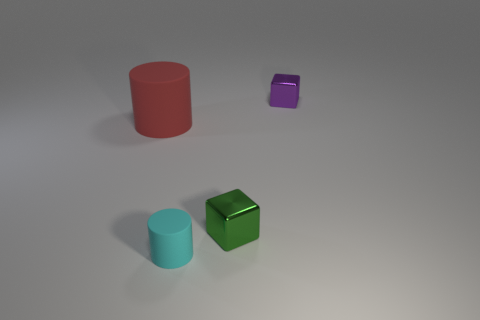Add 1 tiny cyan cylinders. How many objects exist? 5 Subtract all purple metal cubes. Subtract all green blocks. How many objects are left? 2 Add 3 big rubber objects. How many big rubber objects are left? 4 Add 2 cyan rubber things. How many cyan rubber things exist? 3 Subtract 1 red cylinders. How many objects are left? 3 